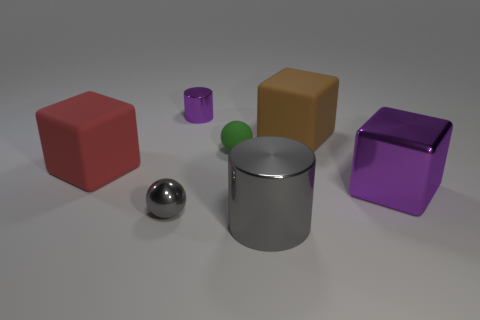There is a gray sphere that is the same material as the large purple object; what size is it?
Give a very brief answer. Small. How many large red objects are the same shape as the small purple metal object?
Make the answer very short. 0. Are the big gray cylinder and the cylinder behind the green ball made of the same material?
Make the answer very short. Yes. Is the number of large purple metal things that are behind the large purple cube greater than the number of small blue balls?
Provide a succinct answer. No. The big thing that is the same color as the tiny shiny ball is what shape?
Offer a very short reply. Cylinder. Is there a tiny gray sphere made of the same material as the tiny green ball?
Keep it short and to the point. No. Is the material of the purple object that is left of the gray cylinder the same as the large object that is to the left of the big gray cylinder?
Keep it short and to the point. No. Are there an equal number of large rubber cubes that are left of the big gray metal object and spheres that are in front of the tiny shiny sphere?
Your response must be concise. No. The metal block that is the same size as the gray cylinder is what color?
Your answer should be very brief. Purple. Is there a block that has the same color as the metallic sphere?
Your answer should be very brief. No. 